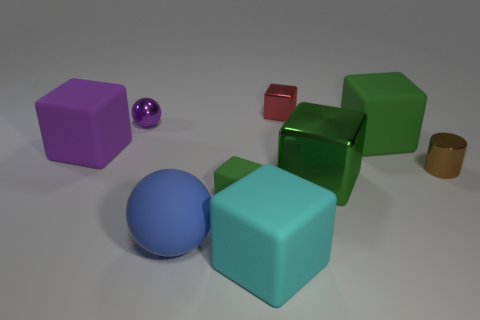There is a tiny purple thing that is the same material as the small brown cylinder; what is its shape?
Provide a short and direct response. Sphere. There is a matte cube that is in front of the blue rubber thing left of the green metal block; how many large objects are in front of it?
Keep it short and to the point. 0. There is a sphere that is on the left side of the blue matte thing; is it the same size as the large metallic cube?
Ensure brevity in your answer.  No. Is the number of large cyan rubber things behind the brown thing less than the number of large metal things right of the large green metallic block?
Offer a very short reply. No. Is the color of the small matte thing the same as the large ball?
Keep it short and to the point. No. There is a large cube that is the same color as the large metallic object; what material is it?
Ensure brevity in your answer.  Rubber. Does the purple ball have the same material as the brown cylinder?
Provide a succinct answer. Yes. There is a tiny cube that is made of the same material as the blue thing; what color is it?
Your answer should be very brief. Green. There is a green block that is left of the red object; what is it made of?
Ensure brevity in your answer.  Rubber. What shape is the green rubber thing that is the same size as the cyan matte cube?
Keep it short and to the point. Cube. 